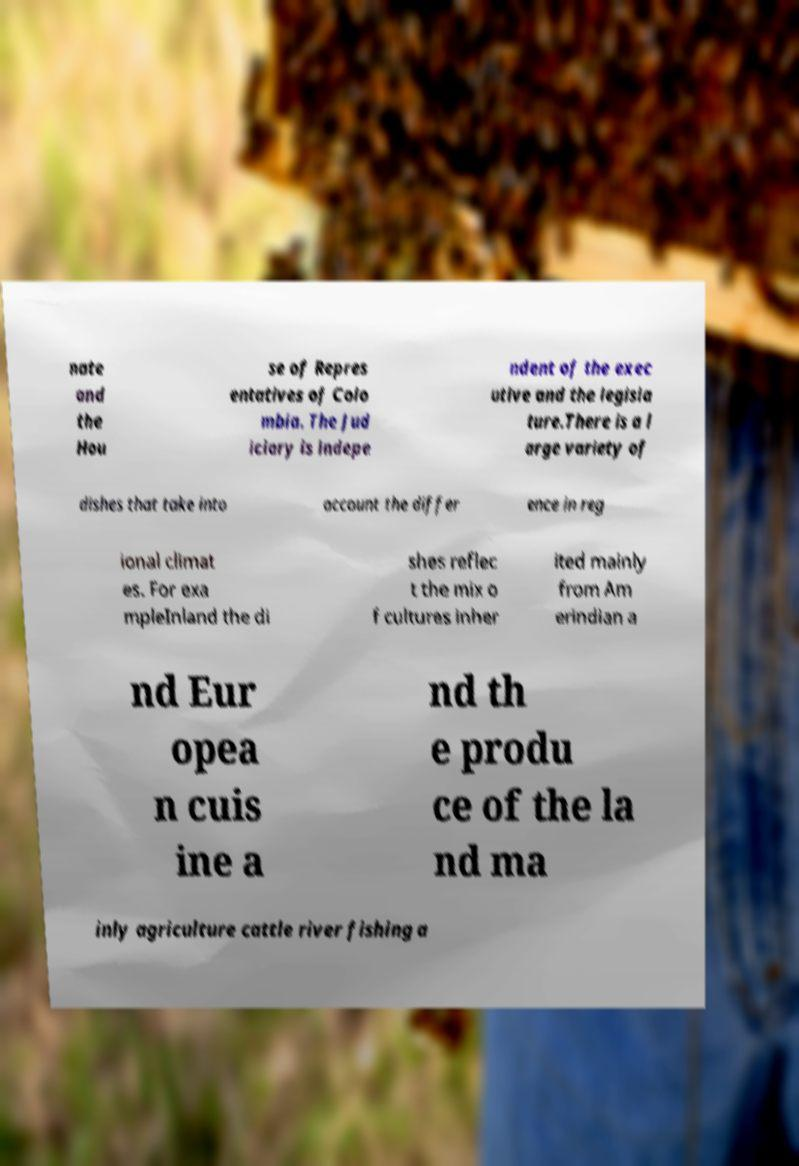For documentation purposes, I need the text within this image transcribed. Could you provide that? nate and the Hou se of Repres entatives of Colo mbia. The Jud iciary is indepe ndent of the exec utive and the legisla ture.There is a l arge variety of dishes that take into account the differ ence in reg ional climat es. For exa mpleInland the di shes reflec t the mix o f cultures inher ited mainly from Am erindian a nd Eur opea n cuis ine a nd th e produ ce of the la nd ma inly agriculture cattle river fishing a 